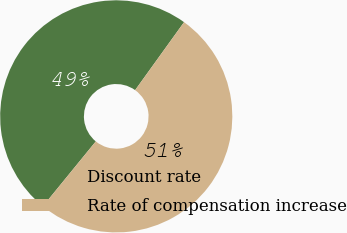<chart> <loc_0><loc_0><loc_500><loc_500><pie_chart><fcel>Discount rate<fcel>Rate of compensation increase<nl><fcel>49.04%<fcel>50.96%<nl></chart> 